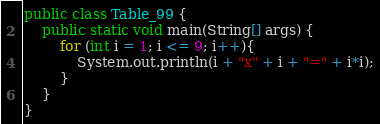Convert code to text. <code><loc_0><loc_0><loc_500><loc_500><_Java_>public class Table_99 {
	public static void main(String[] args) {
        for (int i = 1; i <= 9; i++){
        	System.out.println(i + "x" + i + "=" + i*i);
        }
    }
}</code> 